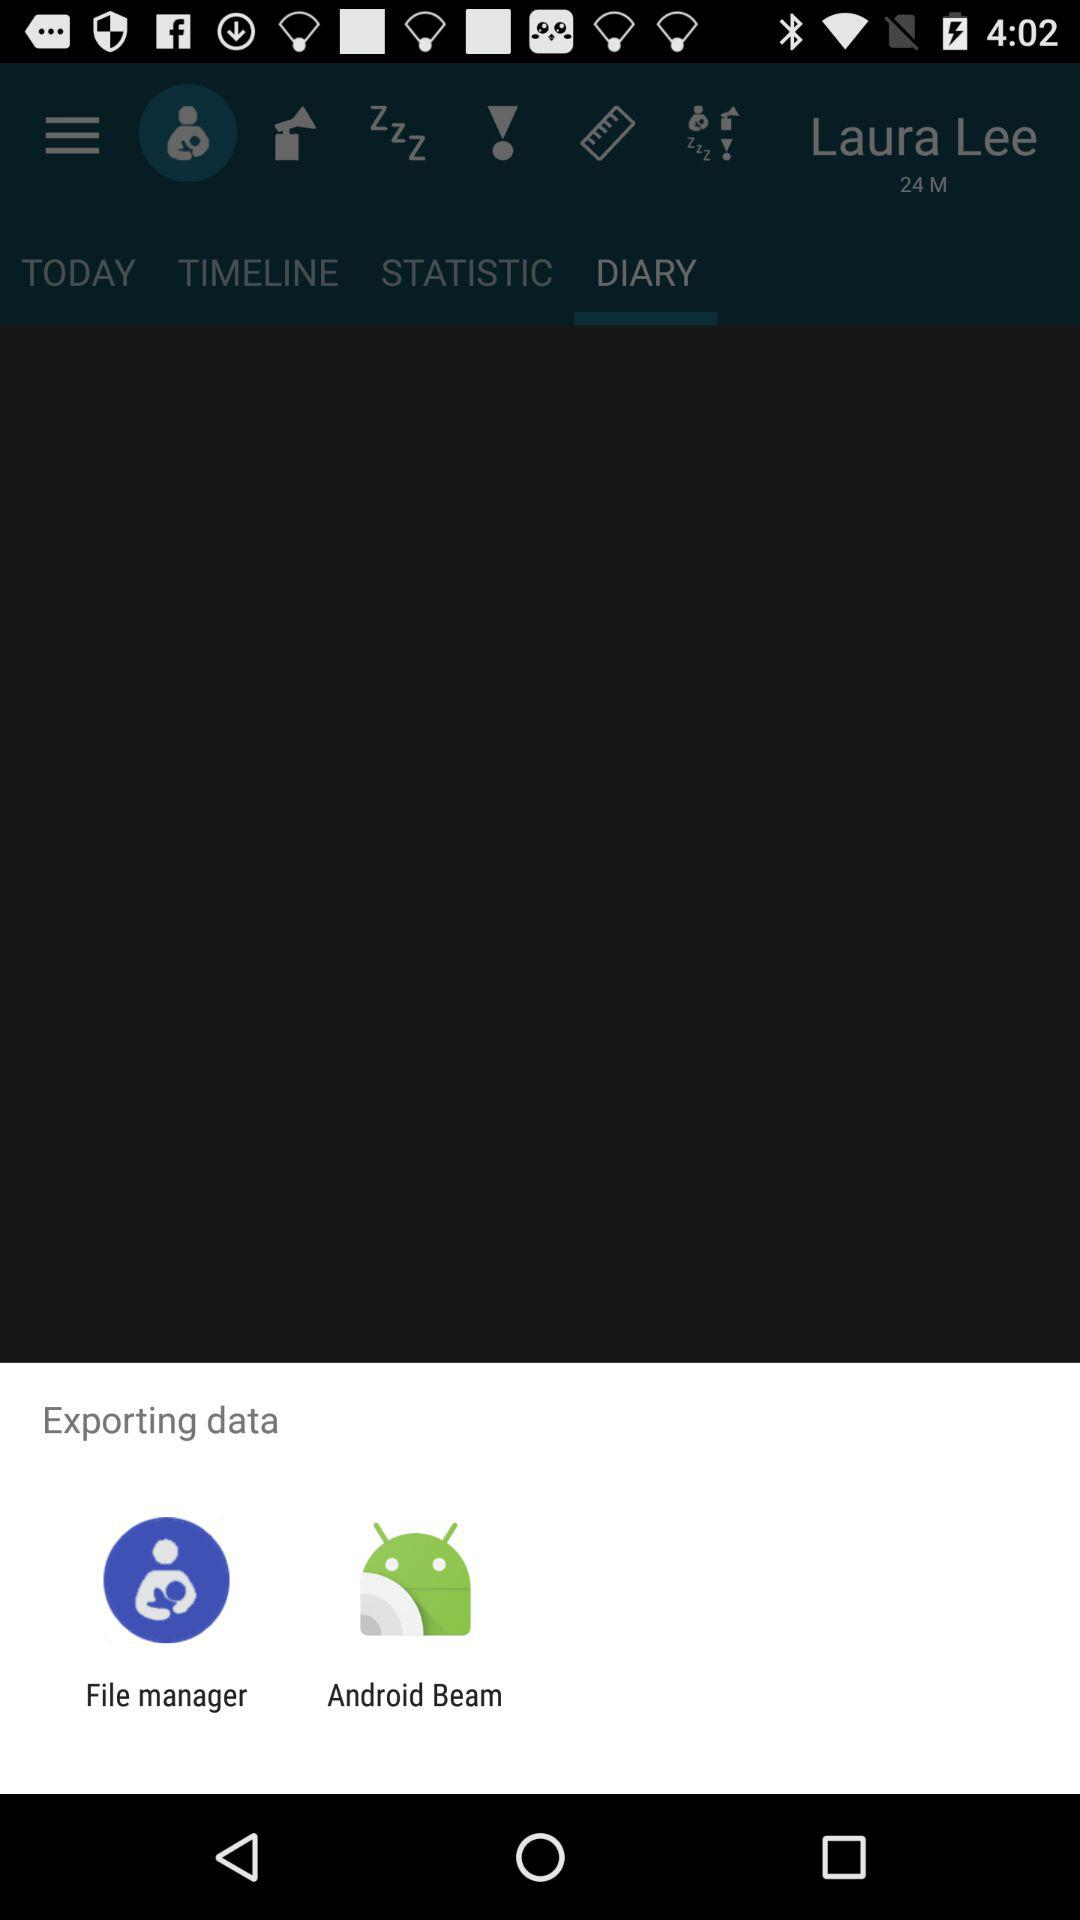What is the age of the user? The user is 24 years old. 